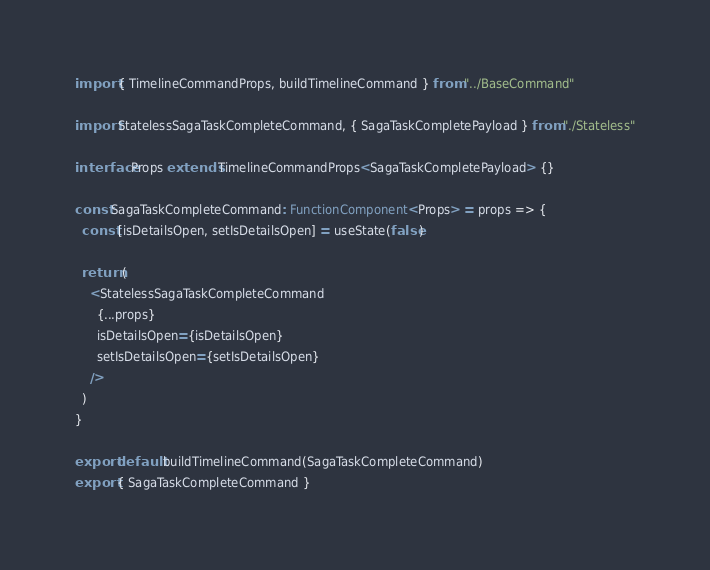Convert code to text. <code><loc_0><loc_0><loc_500><loc_500><_TypeScript_>
import { TimelineCommandProps, buildTimelineCommand } from "../BaseCommand"

import StatelessSagaTaskCompleteCommand, { SagaTaskCompletePayload } from "./Stateless"

interface Props extends TimelineCommandProps<SagaTaskCompletePayload> {}

const SagaTaskCompleteCommand: FunctionComponent<Props> = props => {
  const [isDetailsOpen, setIsDetailsOpen] = useState(false)

  return (
    <StatelessSagaTaskCompleteCommand
      {...props}
      isDetailsOpen={isDetailsOpen}
      setIsDetailsOpen={setIsDetailsOpen}
    />
  )
}

export default buildTimelineCommand(SagaTaskCompleteCommand)
export { SagaTaskCompleteCommand }
</code> 